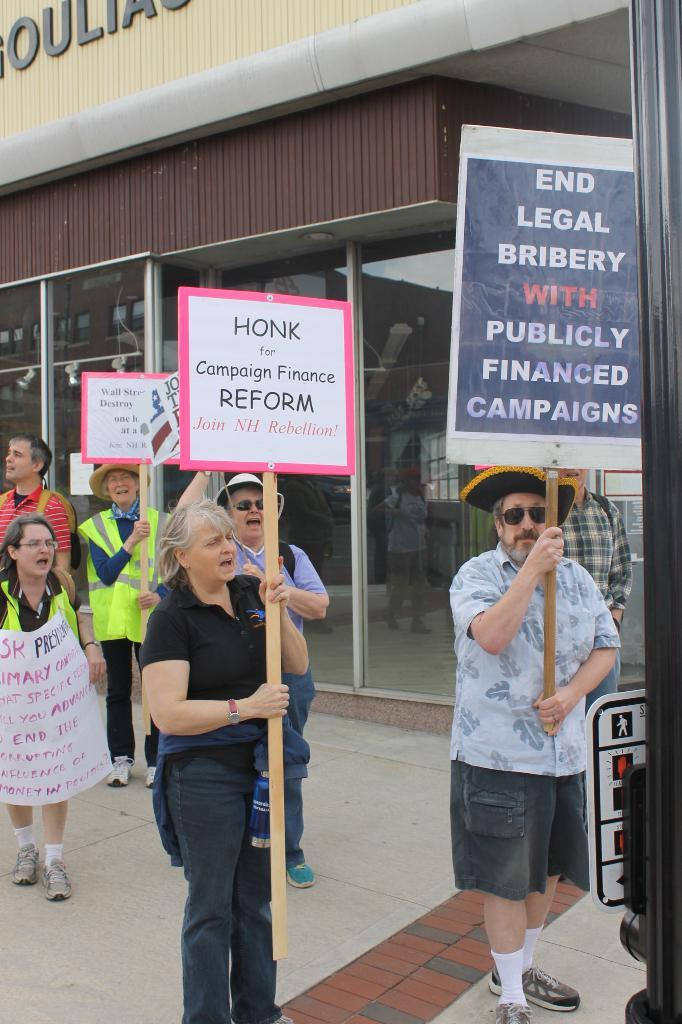What is happening in the image involving the group of people? The people in the image are holding images with writing on them. Can you describe the background of the image? There is a small restaurant and a road visible in the background. What might the images with writing on them represent? The images with writing on them could represent signs, posters, or messages being held by the group of people. Is there a flame visible in the image? No, there is no flame present in the image. 